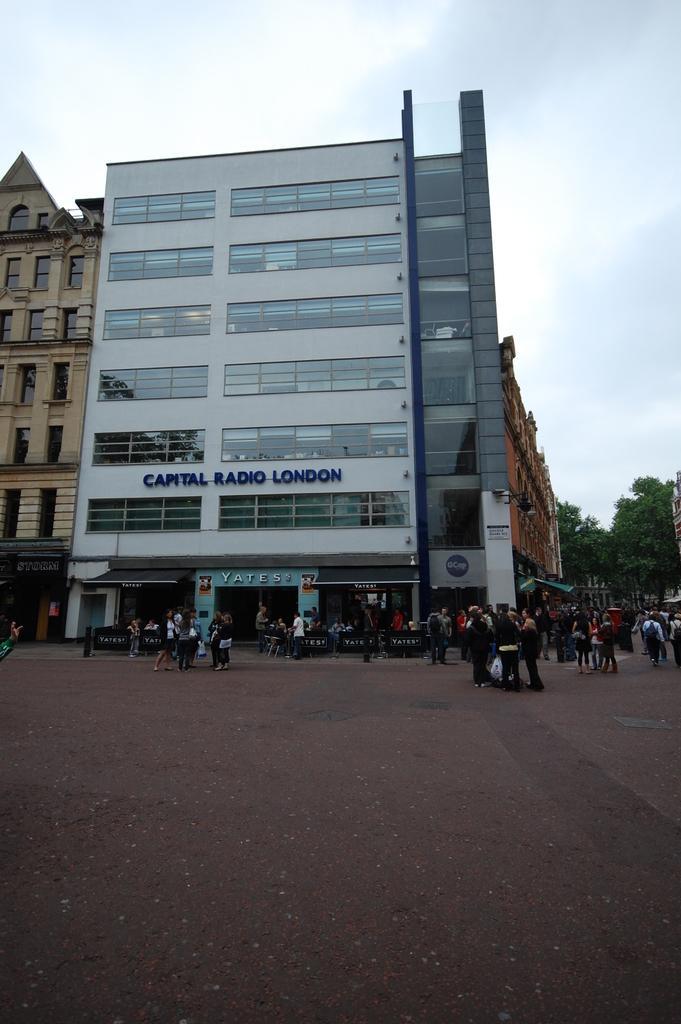Please provide a concise description of this image. In this image in the center there are buildings, on the buildings there is text and there are some trees and group of people. At the bottom there is walkway, and at the top there is text. 